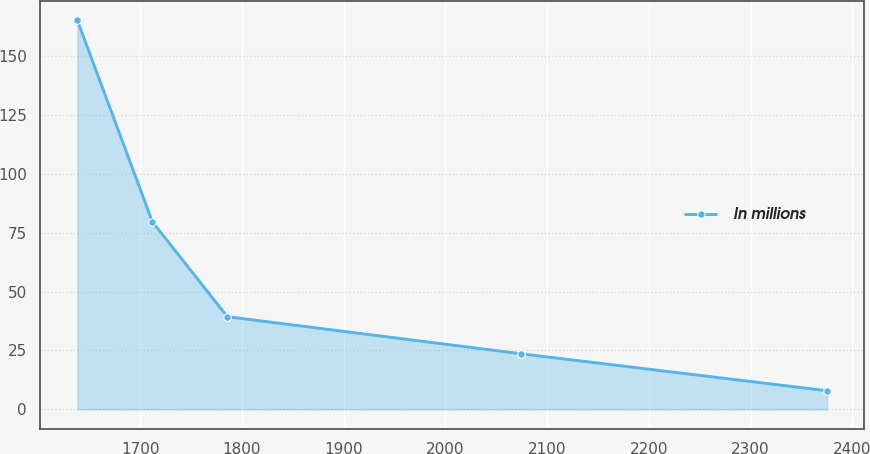Convert chart. <chart><loc_0><loc_0><loc_500><loc_500><line_chart><ecel><fcel>In millions<nl><fcel>1638.16<fcel>164.96<nl><fcel>1711.85<fcel>79.59<nl><fcel>1785.54<fcel>39.33<nl><fcel>2073.79<fcel>23.63<nl><fcel>2375.06<fcel>7.93<nl></chart> 